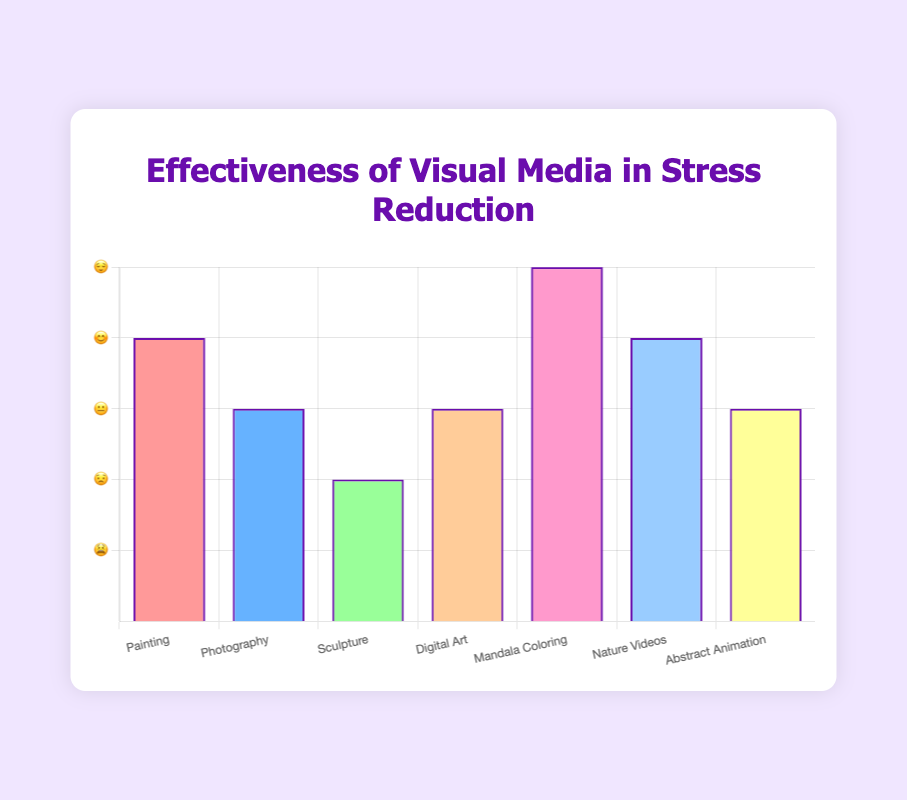What is the title of the chart? The title is usually located at the top of the chart, and it reads "Effectiveness of Visual Media in Stress Reduction" as seen clearly in the figure.
Answer: Effectiveness of Visual Media in Stress Reduction How many types of visual media are represented in the chart? By counting the number of labels on the x-axis, we find there are 7 types of visual media.
Answer: 7 Which type of visual media has the highest stress reduction level? By looking at the height of the bars in the bar chart, we see that "Mandala Coloring" has the highest bar, indicating the highest stress reduction level.
Answer: Mandala Coloring What stress reduction level is associated with Nature Videos, and what emoji represents it? The bar for "Nature Videos" reaches the fourth tick mark on the y-axis. Referring to the y-axis, the fourth tick mark corresponds to an emoji scale value of 4, represented by "😊".
Answer: 4, 😊 How many visual media types have a stress reduction level of 3? By examining the chart, "Photography", "Digital Art", and "Abstract Animation" all have bars that reach the third tick mark, which is level 3.
Answer: 3 Compare the stress reduction level of Painting and Sculpture. Which is higher? By comparing the heights of the bars for "Painting" and "Sculpture", we observe that "Painting" has a bar reaching the fourth tick mark, while "Sculpture" reaches the second. Thus, "Painting" is higher.
Answer: Painting What is the average stress reduction level of all visual media types? To find the average, sum all stress reduction levels (4 + 3 + 2 + 3 + 5 + 4 + 3 = 24) and divide by the number of media types (7). So the average is 24/7 ≈ 3.43.
Answer: 3.43 Which visual media types have the same stress reduction level, and what is that level? Both "Photography", "Digital Art", and "Abstract Animation" have bars at level 3, as indicated by their heights.
Answer: Photography, Digital Art, Abstract Animation, 3 Between Mandala Coloring and Nature Videos, which has the greater stress reduction level and by how much? "Mandala Coloring" is at level 5, and "Nature Videos" is at level 4. Therefore, the difference is 5 - 4 = 1.
Answer: Mandala Coloring, by 1 What is the difference in stress reduction level between the highest and lowest visual media types? The highest level is 5 (Mandala Coloring) and the lowest level is 2 (Sculpture). The difference is 5 - 2 = 3.
Answer: 3 